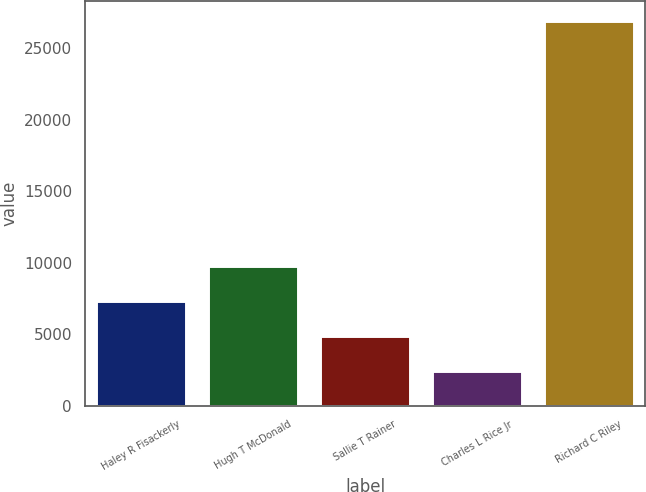Convert chart. <chart><loc_0><loc_0><loc_500><loc_500><bar_chart><fcel>Haley R Fisackerly<fcel>Hugh T McDonald<fcel>Sallie T Rainer<fcel>Charles L Rice Jr<fcel>Richard C Riley<nl><fcel>7362.2<fcel>9805.8<fcel>4918.6<fcel>2475<fcel>26911<nl></chart> 